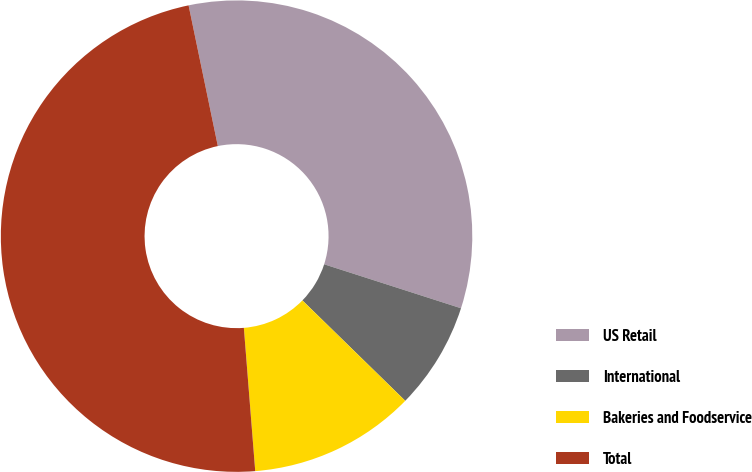<chart> <loc_0><loc_0><loc_500><loc_500><pie_chart><fcel>US Retail<fcel>International<fcel>Bakeries and Foodservice<fcel>Total<nl><fcel>33.21%<fcel>7.36%<fcel>11.43%<fcel>48.0%<nl></chart> 